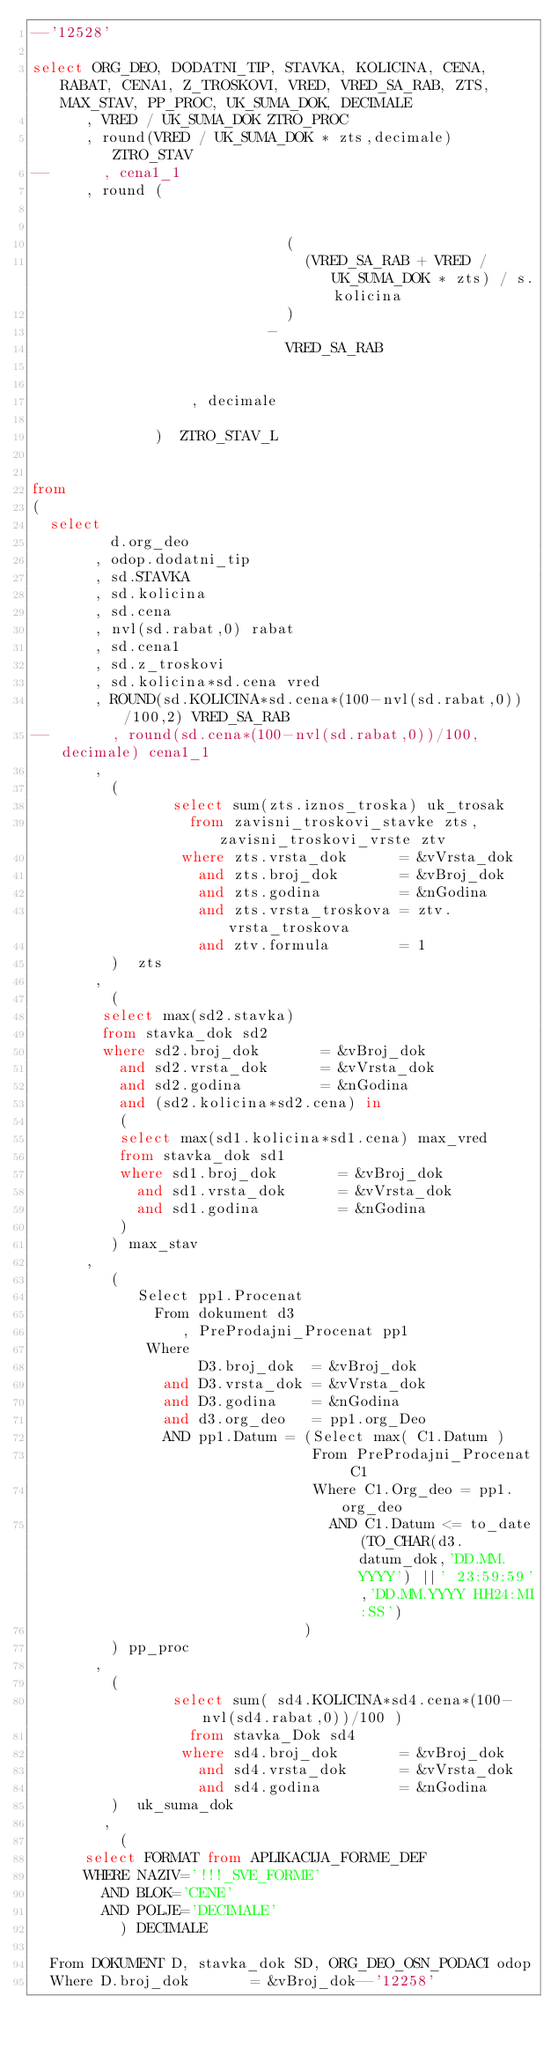Convert code to text. <code><loc_0><loc_0><loc_500><loc_500><_SQL_>--'12528'

select ORG_DEO, DODATNI_TIP, STAVKA, KOLICINA, CENA, RABAT, CENA1, Z_TROSKOVI, VRED, VRED_SA_RAB, ZTS, MAX_STAV, PP_PROC, UK_SUMA_DOK, DECIMALE
      , VRED / UK_SUMA_DOK ZTRO_PROC
      , round(VRED / UK_SUMA_DOK * zts,decimale) ZTRO_STAV
--      , cena1_1
      , round (


	                           (
	                             (VRED_SA_RAB + VRED / UK_SUMA_DOK * zts) / s.kolicina
	                           )
	                         -
	                           VRED_SA_RAB


                  , decimale

              )  ZTRO_STAV_L


from
(
	select
	       d.org_deo
	     , odop.dodatni_tip
	     , sd.STAVKA
	     , sd.kolicina
	     , sd.cena
	     , nvl(sd.rabat,0) rabat
	     , sd.cena1
	     , sd.z_troskovi
	     , sd.kolicina*sd.cena vred
	     , ROUND(sd.KOLICINA*sd.cena*(100-nvl(sd.rabat,0))/100,2) VRED_SA_RAB
--	     , round(sd.cena*(100-nvl(sd.rabat,0))/100,decimale) cena1_1
	     ,
	       (
	              select sum(zts.iznos_troska) uk_trosak
	                from zavisni_troskovi_stavke zts, zavisni_troskovi_vrste ztv
	               where zts.vrsta_dok      = &vVrsta_dok
	                 and zts.broj_dok       = &vBroj_dok
	                 and zts.godina         = &nGodina
	                 and zts.vrsta_troskova = ztv.vrsta_troskova
	                 and ztv.formula        = 1
	       )  zts
	     ,
	       (
				select max(sd2.stavka)
				from stavka_dok sd2
				where sd2.broj_dok       = &vBroj_dok
				  and sd2.vrsta_dok      = &vVrsta_dok
				  and sd2.godina         = &nGodina
				  and (sd2.kolicina*sd2.cena) in
				  (
					select max(sd1.kolicina*sd1.cena) max_vred
					from stavka_dok sd1
					where sd1.broj_dok       = &vBroj_dok
					  and sd1.vrsta_dok      = &vVrsta_dok
					  and sd1.godina         = &nGodina
				  )
	       ) max_stav
	    ,
	       (
		        Select pp1.Procenat
		          From dokument d3
		             , PreProdajni_Procenat pp1
		         Where
		               D3.broj_dok  = &vBroj_dok
		           and D3.vrsta_dok = &vVrsta_dok
		           and D3.godina    = &nGodina
		           and d3.org_deo   = pp1.org_Deo
		           AND pp1.Datum = (Select max( C1.Datum )
		                            From PreProdajni_Procenat C1
		                            Where C1.Org_deo = pp1.org_deo
		                              AND C1.Datum <= to_date(TO_CHAR(d3.datum_dok,'DD.MM.YYYY') ||' 23:59:59','DD.MM.YYYY HH24:MI:SS')
		                           )
	       ) pp_proc
	     ,
	       (
	              select sum( sd4.KOLICINA*sd4.cena*(100-nvl(sd4.rabat,0))/100 )
	                from stavka_Dok sd4
	               where sd4.broj_dok       = &vBroj_dok
	                 and sd4.vrsta_dok      = &vVrsta_dok
	                 and sd4.godina         = &nGodina
	       )  uk_suma_dok
        ,
          (
			select FORMAT from APLIKACIJA_FORME_DEF
			WHERE NAZIV='!!!_SVE_FORME'
			  AND BLOK='CENE'
			  AND POLJE='DECIMALE'
          ) DECIMALE

	From DOKUMENT D, stavka_dok SD, ORG_DEO_OSN_PODACI odop
	Where D.broj_dok       = &vBroj_dok--'12258'</code> 